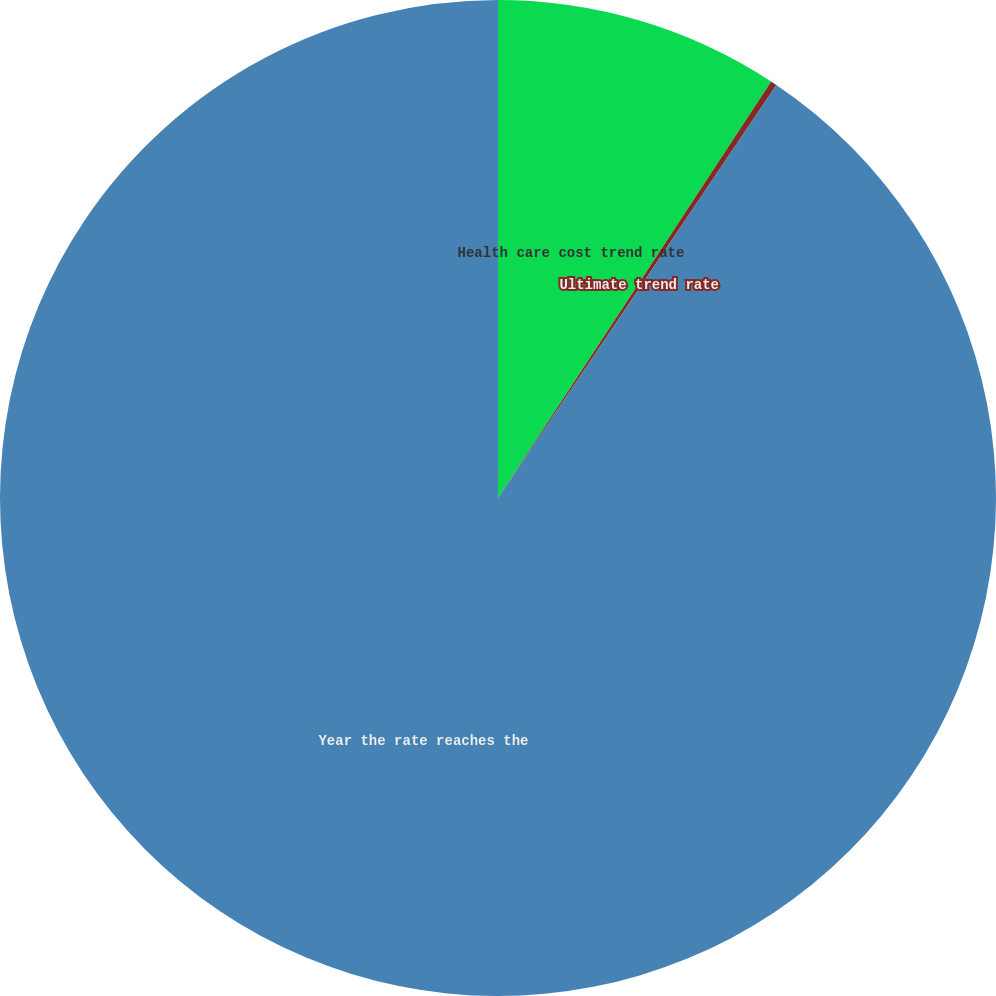Convert chart to OTSL. <chart><loc_0><loc_0><loc_500><loc_500><pie_chart><fcel>Health care cost trend rate<fcel>Ultimate trend rate<fcel>Year the rate reaches the<nl><fcel>9.24%<fcel>0.2%<fcel>90.56%<nl></chart> 